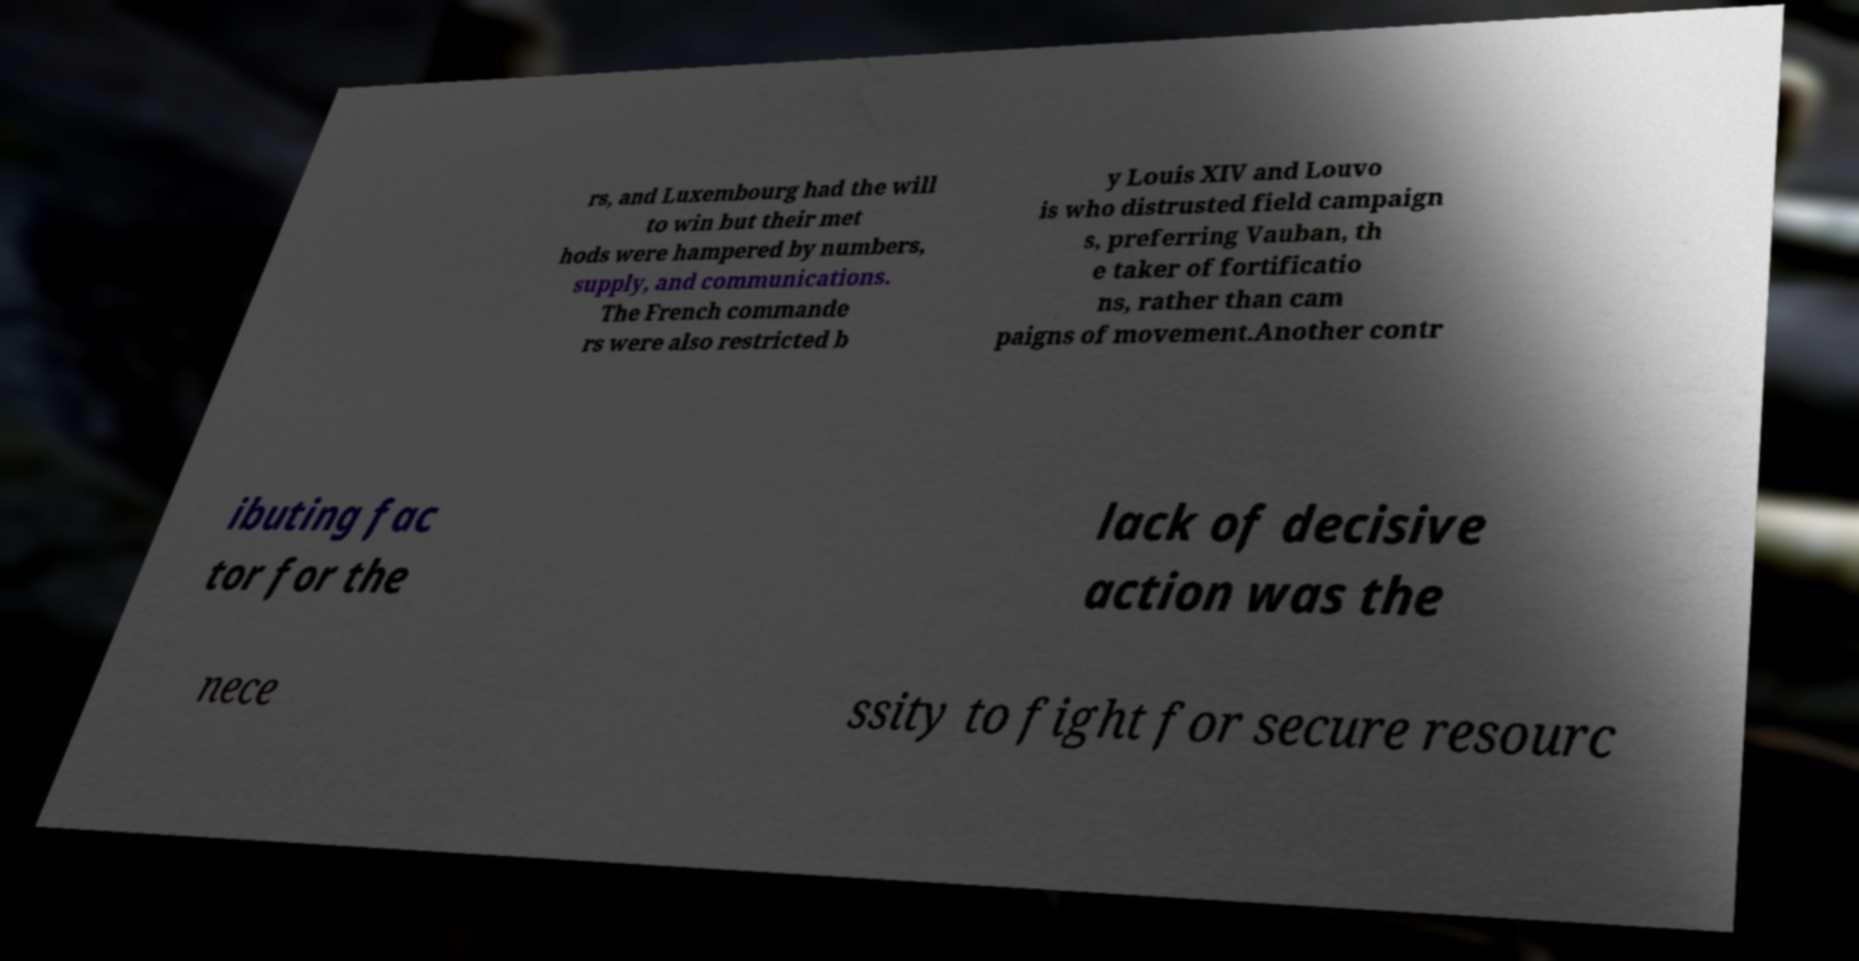Could you extract and type out the text from this image? rs, and Luxembourg had the will to win but their met hods were hampered by numbers, supply, and communications. The French commande rs were also restricted b y Louis XIV and Louvo is who distrusted field campaign s, preferring Vauban, th e taker of fortificatio ns, rather than cam paigns of movement.Another contr ibuting fac tor for the lack of decisive action was the nece ssity to fight for secure resourc 